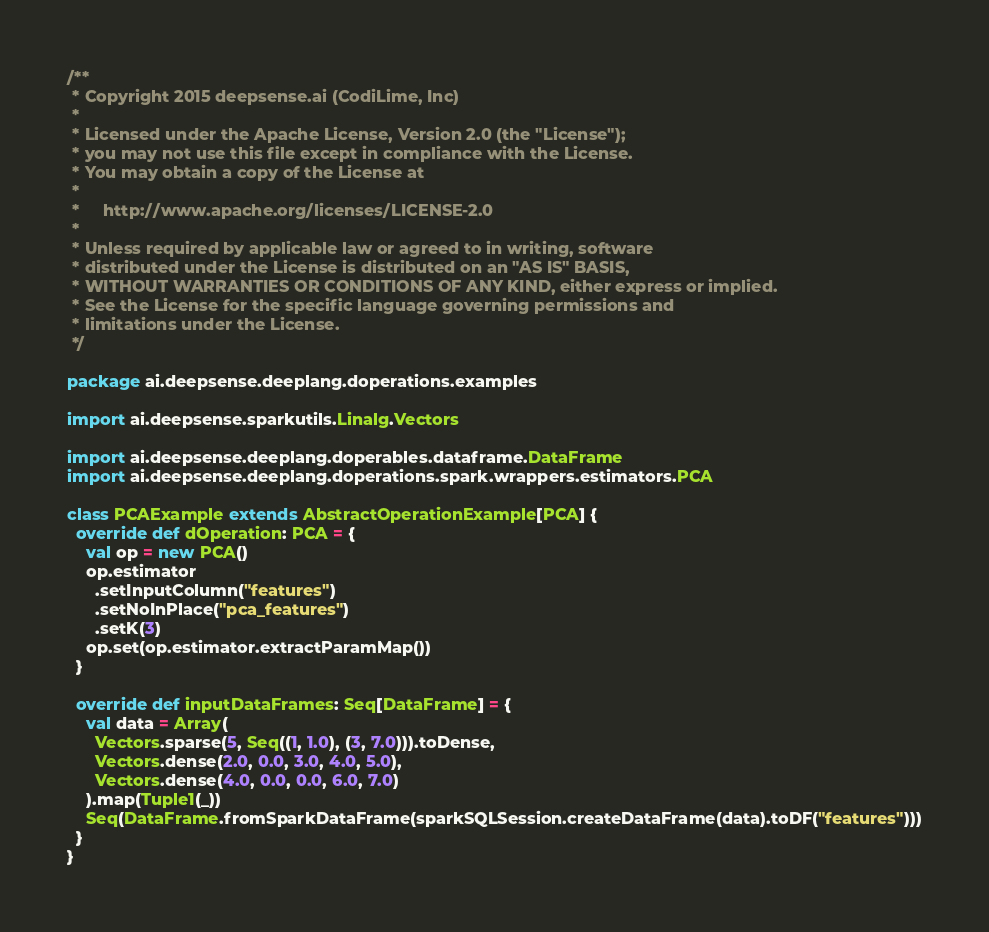<code> <loc_0><loc_0><loc_500><loc_500><_Scala_>/**
 * Copyright 2015 deepsense.ai (CodiLime, Inc)
 *
 * Licensed under the Apache License, Version 2.0 (the "License");
 * you may not use this file except in compliance with the License.
 * You may obtain a copy of the License at
 *
 *     http://www.apache.org/licenses/LICENSE-2.0
 *
 * Unless required by applicable law or agreed to in writing, software
 * distributed under the License is distributed on an "AS IS" BASIS,
 * WITHOUT WARRANTIES OR CONDITIONS OF ANY KIND, either express or implied.
 * See the License for the specific language governing permissions and
 * limitations under the License.
 */

package ai.deepsense.deeplang.doperations.examples

import ai.deepsense.sparkutils.Linalg.Vectors

import ai.deepsense.deeplang.doperables.dataframe.DataFrame
import ai.deepsense.deeplang.doperations.spark.wrappers.estimators.PCA

class PCAExample extends AbstractOperationExample[PCA] {
  override def dOperation: PCA = {
    val op = new PCA()
    op.estimator
      .setInputColumn("features")
      .setNoInPlace("pca_features")
      .setK(3)
    op.set(op.estimator.extractParamMap())
  }

  override def inputDataFrames: Seq[DataFrame] = {
    val data = Array(
      Vectors.sparse(5, Seq((1, 1.0), (3, 7.0))).toDense,
      Vectors.dense(2.0, 0.0, 3.0, 4.0, 5.0),
      Vectors.dense(4.0, 0.0, 0.0, 6.0, 7.0)
    ).map(Tuple1(_))
    Seq(DataFrame.fromSparkDataFrame(sparkSQLSession.createDataFrame(data).toDF("features")))
  }
}
</code> 